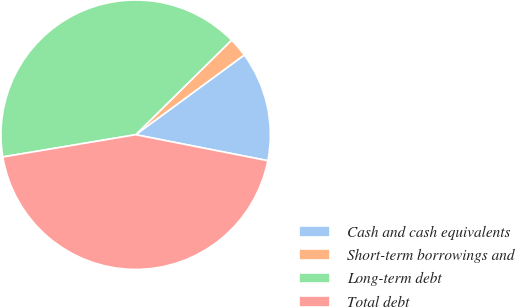Convert chart. <chart><loc_0><loc_0><loc_500><loc_500><pie_chart><fcel>Cash and cash equivalents<fcel>Short-term borrowings and<fcel>Long-term debt<fcel>Total debt<nl><fcel>13.17%<fcel>2.31%<fcel>40.25%<fcel>44.27%<nl></chart> 